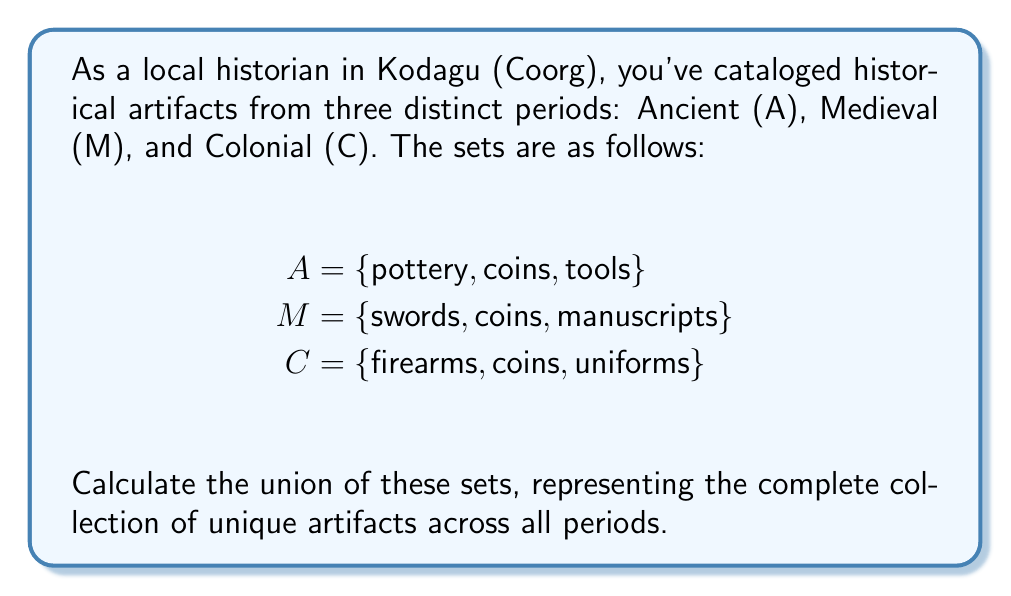Help me with this question. To solve this problem, we need to understand the concept of set union and apply it to the given sets. The union of sets A, M, and C, denoted as $A \cup M \cup C$, includes all unique elements that appear in at least one of the sets.

Let's break down the process:

1. List all elements from set A:
   {pottery, coins, tools}

2. Add unique elements from set M:
   {pottery, coins, tools, swords, manuscripts}
   Note: 'coins' is already included, so we don't add it again.

3. Add unique elements from set C:
   {pottery, coins, tools, swords, manuscripts, firearms, uniforms}
   Note: 'coins' is already included, so we don't add it again.

4. The resulting set is the union of A, M, and C.

Mathematically, we can express this as:

$$ A \cup M \cup C = \{x : x \in A \text{ or } x \in M \text{ or } x \in C\} $$

Where $x$ represents each element in the unified set.
Answer: $A \cup M \cup C = \{pottery, coins, tools, swords, manuscripts, firearms, uniforms\}$ 